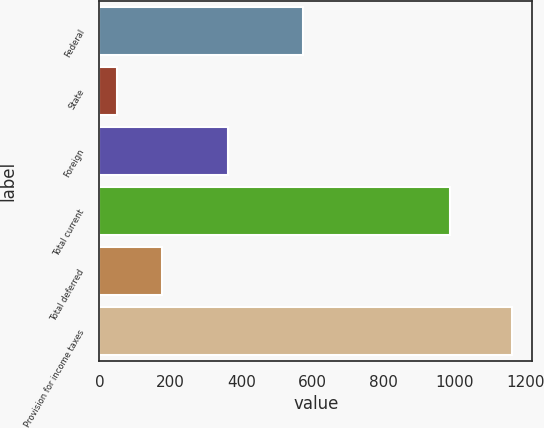Convert chart to OTSL. <chart><loc_0><loc_0><loc_500><loc_500><bar_chart><fcel>Federal<fcel>State<fcel>Foreign<fcel>Total current<fcel>Total deferred<fcel>Provision for income taxes<nl><fcel>574<fcel>50<fcel>363<fcel>987<fcel>175<fcel>1162<nl></chart> 